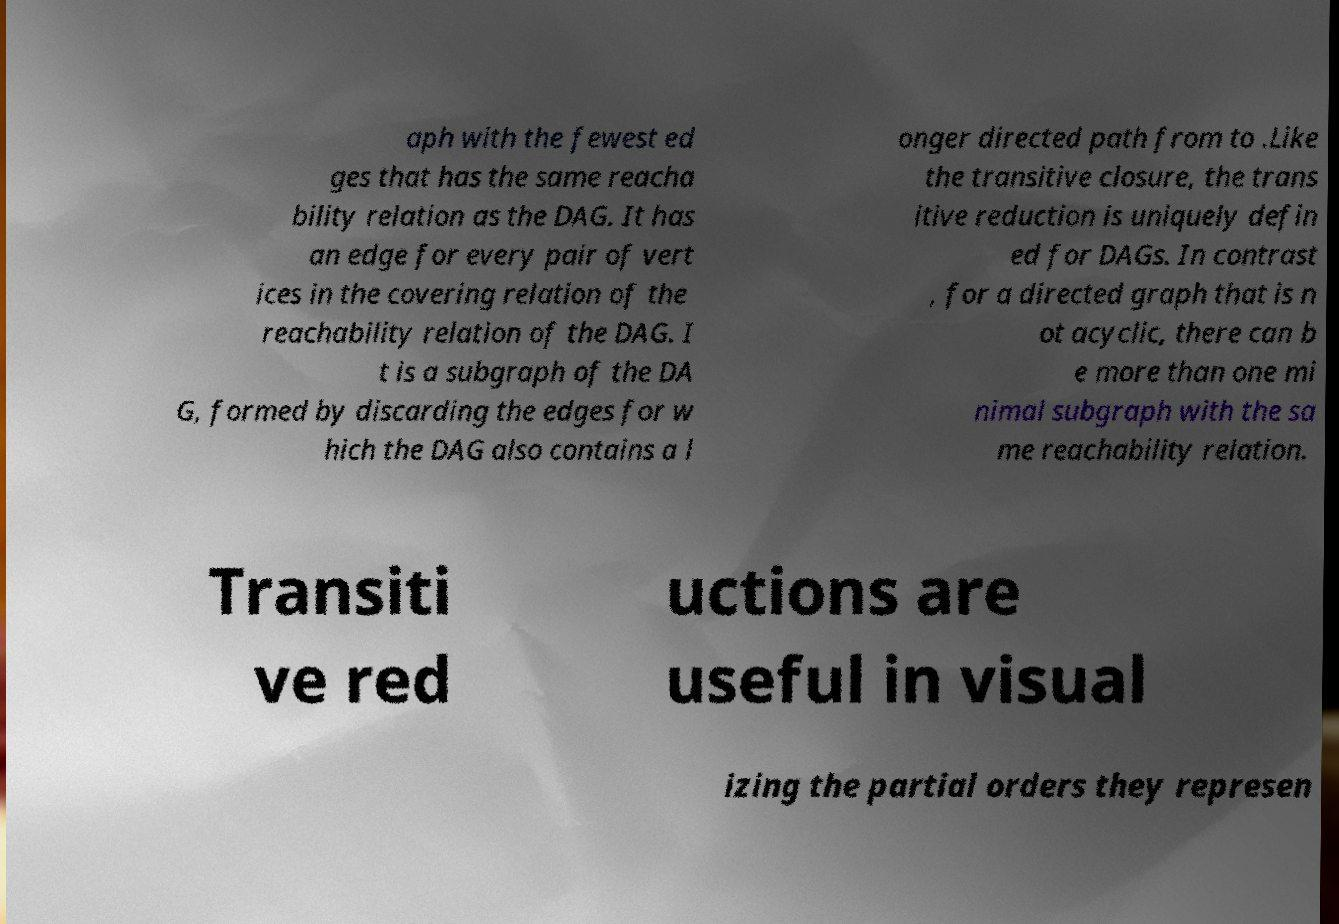Could you assist in decoding the text presented in this image and type it out clearly? aph with the fewest ed ges that has the same reacha bility relation as the DAG. It has an edge for every pair of vert ices in the covering relation of the reachability relation of the DAG. I t is a subgraph of the DA G, formed by discarding the edges for w hich the DAG also contains a l onger directed path from to .Like the transitive closure, the trans itive reduction is uniquely defin ed for DAGs. In contrast , for a directed graph that is n ot acyclic, there can b e more than one mi nimal subgraph with the sa me reachability relation. Transiti ve red uctions are useful in visual izing the partial orders they represen 